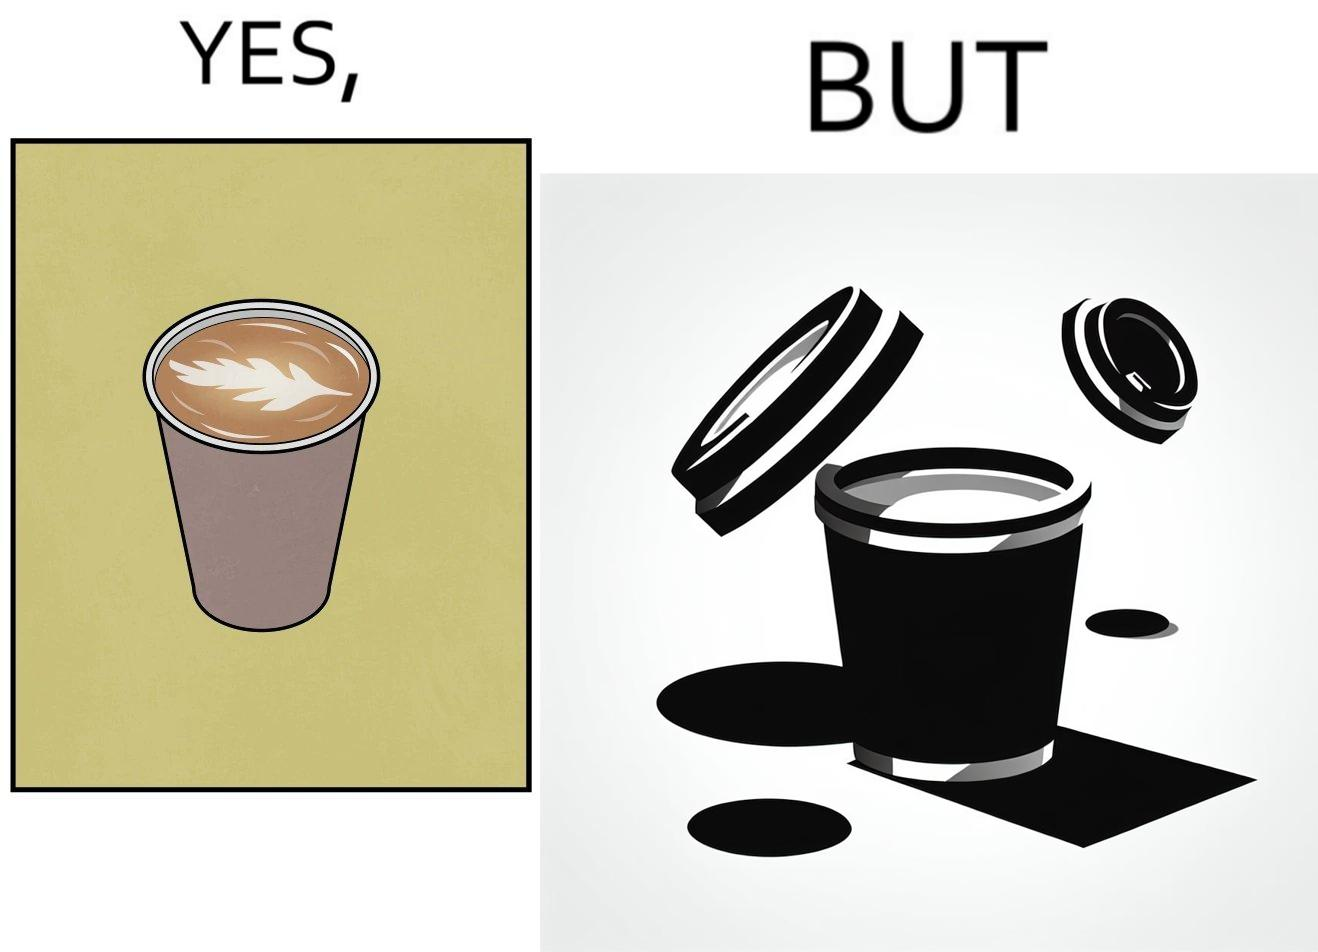Describe what you see in this image. The images are funny since it shows how someone has put effort into a cup of coffee to do latte art on it only for it to be invisible after a lid is put on the coffee cup before serving to a customer 